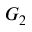Convert formula to latex. <formula><loc_0><loc_0><loc_500><loc_500>G _ { 2 }</formula> 